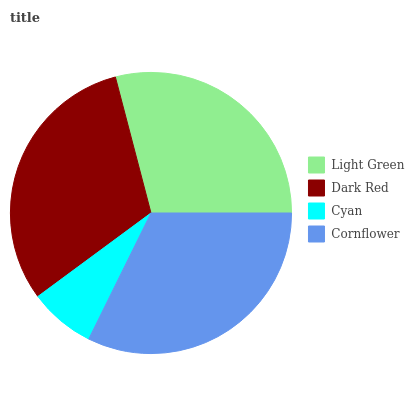Is Cyan the minimum?
Answer yes or no. Yes. Is Cornflower the maximum?
Answer yes or no. Yes. Is Dark Red the minimum?
Answer yes or no. No. Is Dark Red the maximum?
Answer yes or no. No. Is Dark Red greater than Light Green?
Answer yes or no. Yes. Is Light Green less than Dark Red?
Answer yes or no. Yes. Is Light Green greater than Dark Red?
Answer yes or no. No. Is Dark Red less than Light Green?
Answer yes or no. No. Is Dark Red the high median?
Answer yes or no. Yes. Is Light Green the low median?
Answer yes or no. Yes. Is Light Green the high median?
Answer yes or no. No. Is Dark Red the low median?
Answer yes or no. No. 